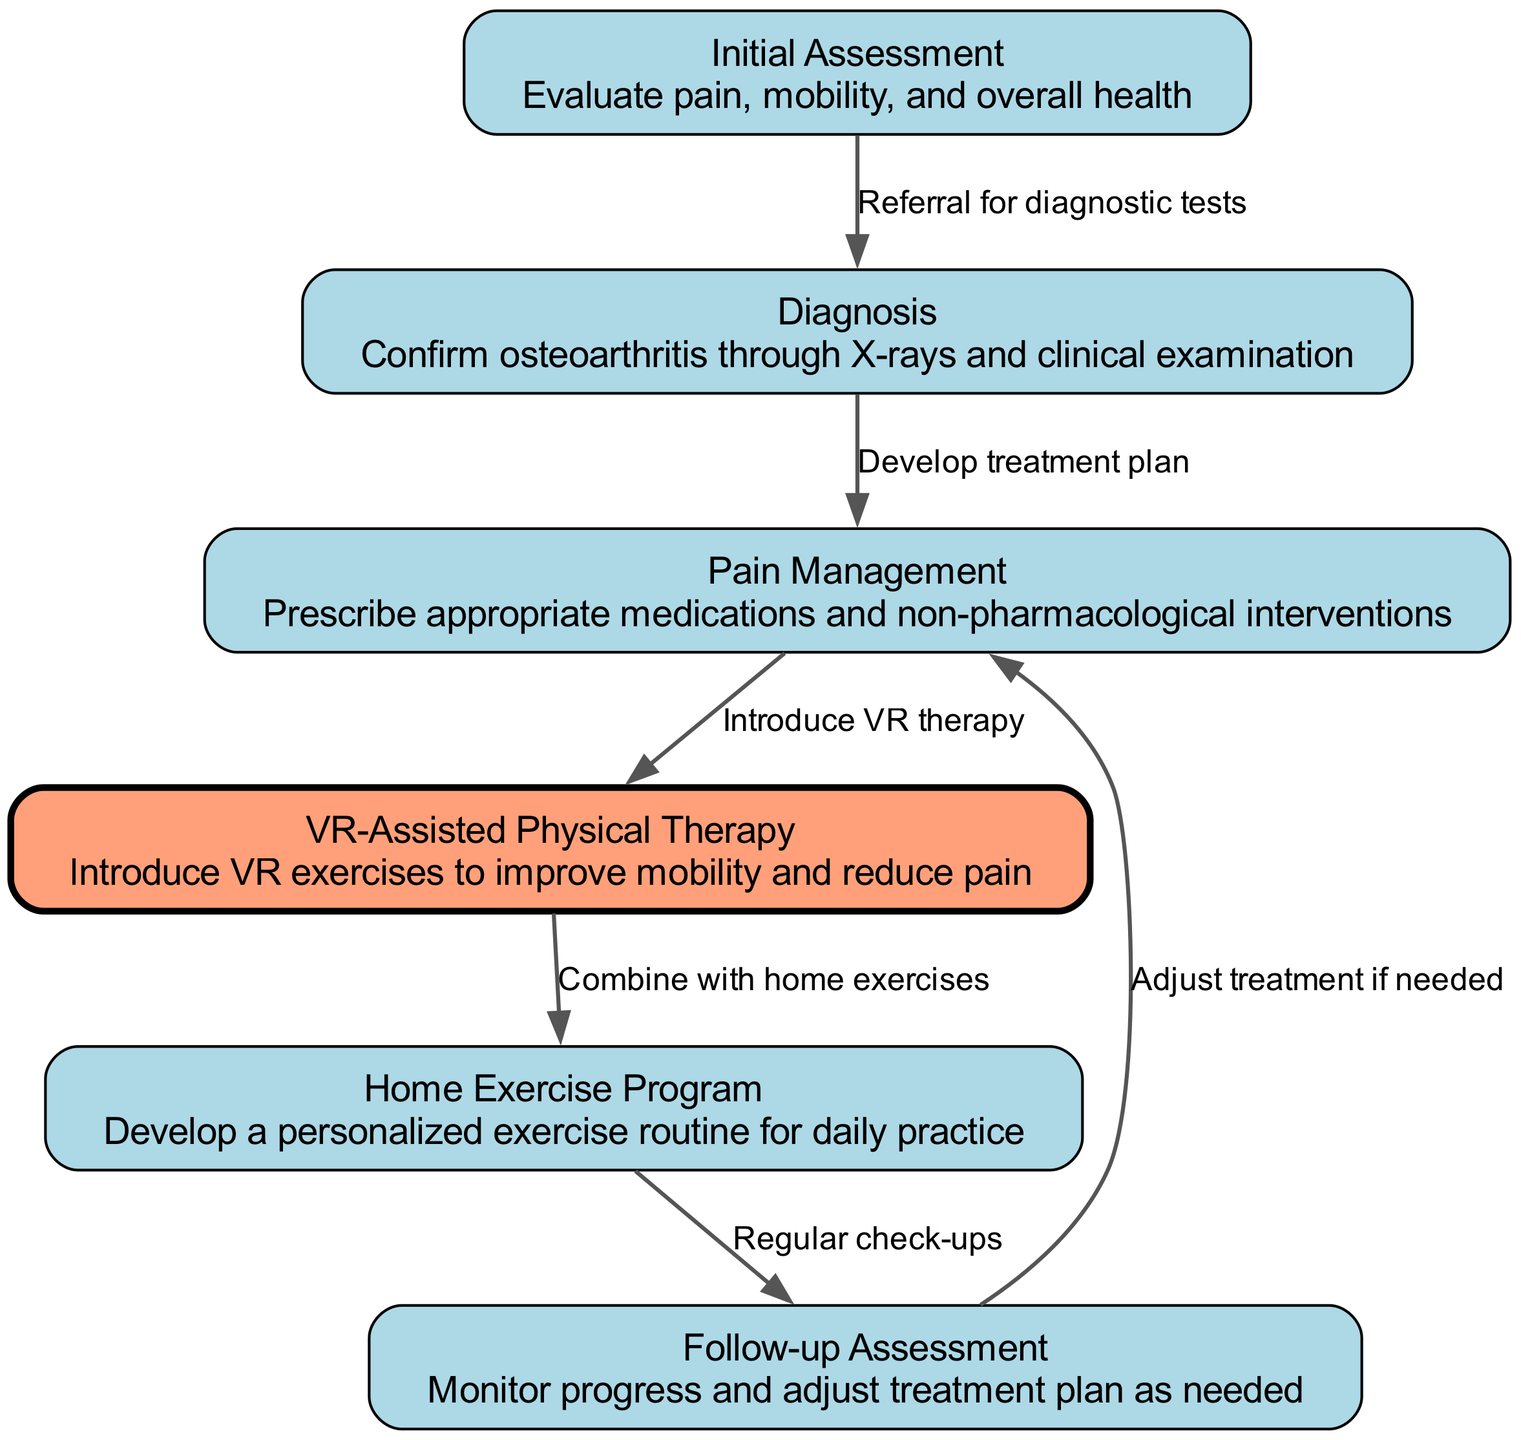What is the first step in the clinical pathway? The diagram starts with the "Initial Assessment" node, indicating it is the beginning of the clinical pathway for managing osteoarthritis.
Answer: Initial Assessment How many nodes are present in the diagram? The diagram contains a total of 6 distinct nodes representing different stages in the clinical pathway.
Answer: 6 What follows after the Diagnosis step? After the "Diagnosis" node, the next node is "Pain Management," which directly follows the diagnostic process.
Answer: Pain Management Which treatment introduces VR technology? The "VR-Assisted Physical Therapy" node is specifically focused on the introduction of VR technology for therapy.
Answer: VR-Assisted Physical Therapy What is combined with VR-assisted physical therapy? The diagram indicates that VR-assisted physical therapy is combined with the "Home Exercise Program" for a holistic treatment approach.
Answer: Home Exercise Program How does the pathway adjust after the Follow-up Assessment? The pathway indicates that adjustments to treatment occur if needed, as depicted by the arrow pointing back to "Pain Management" after the "Follow-up Assessment."
Answer: Adjust treatment if needed What type of exercises are included in the VR-assisted physical therapy? The description of the "VR-Assisted Physical Therapy" node specifies that VR exercises are designed to improve mobility and reduce pain.
Answer: VR exercises Which node involves referral for diagnostic tests? The "Initial Assessment" node leads to the "Diagnosis" step, which involves referral for diagnostic tests based on that initial evaluation.
Answer: Initial Assessment What is the purpose of the Follow-up Assessment? The "Follow-up Assessment" node aims to monitor progress and determine if adjustments to the treatment plan are necessary based on patient responses.
Answer: Monitor progress 